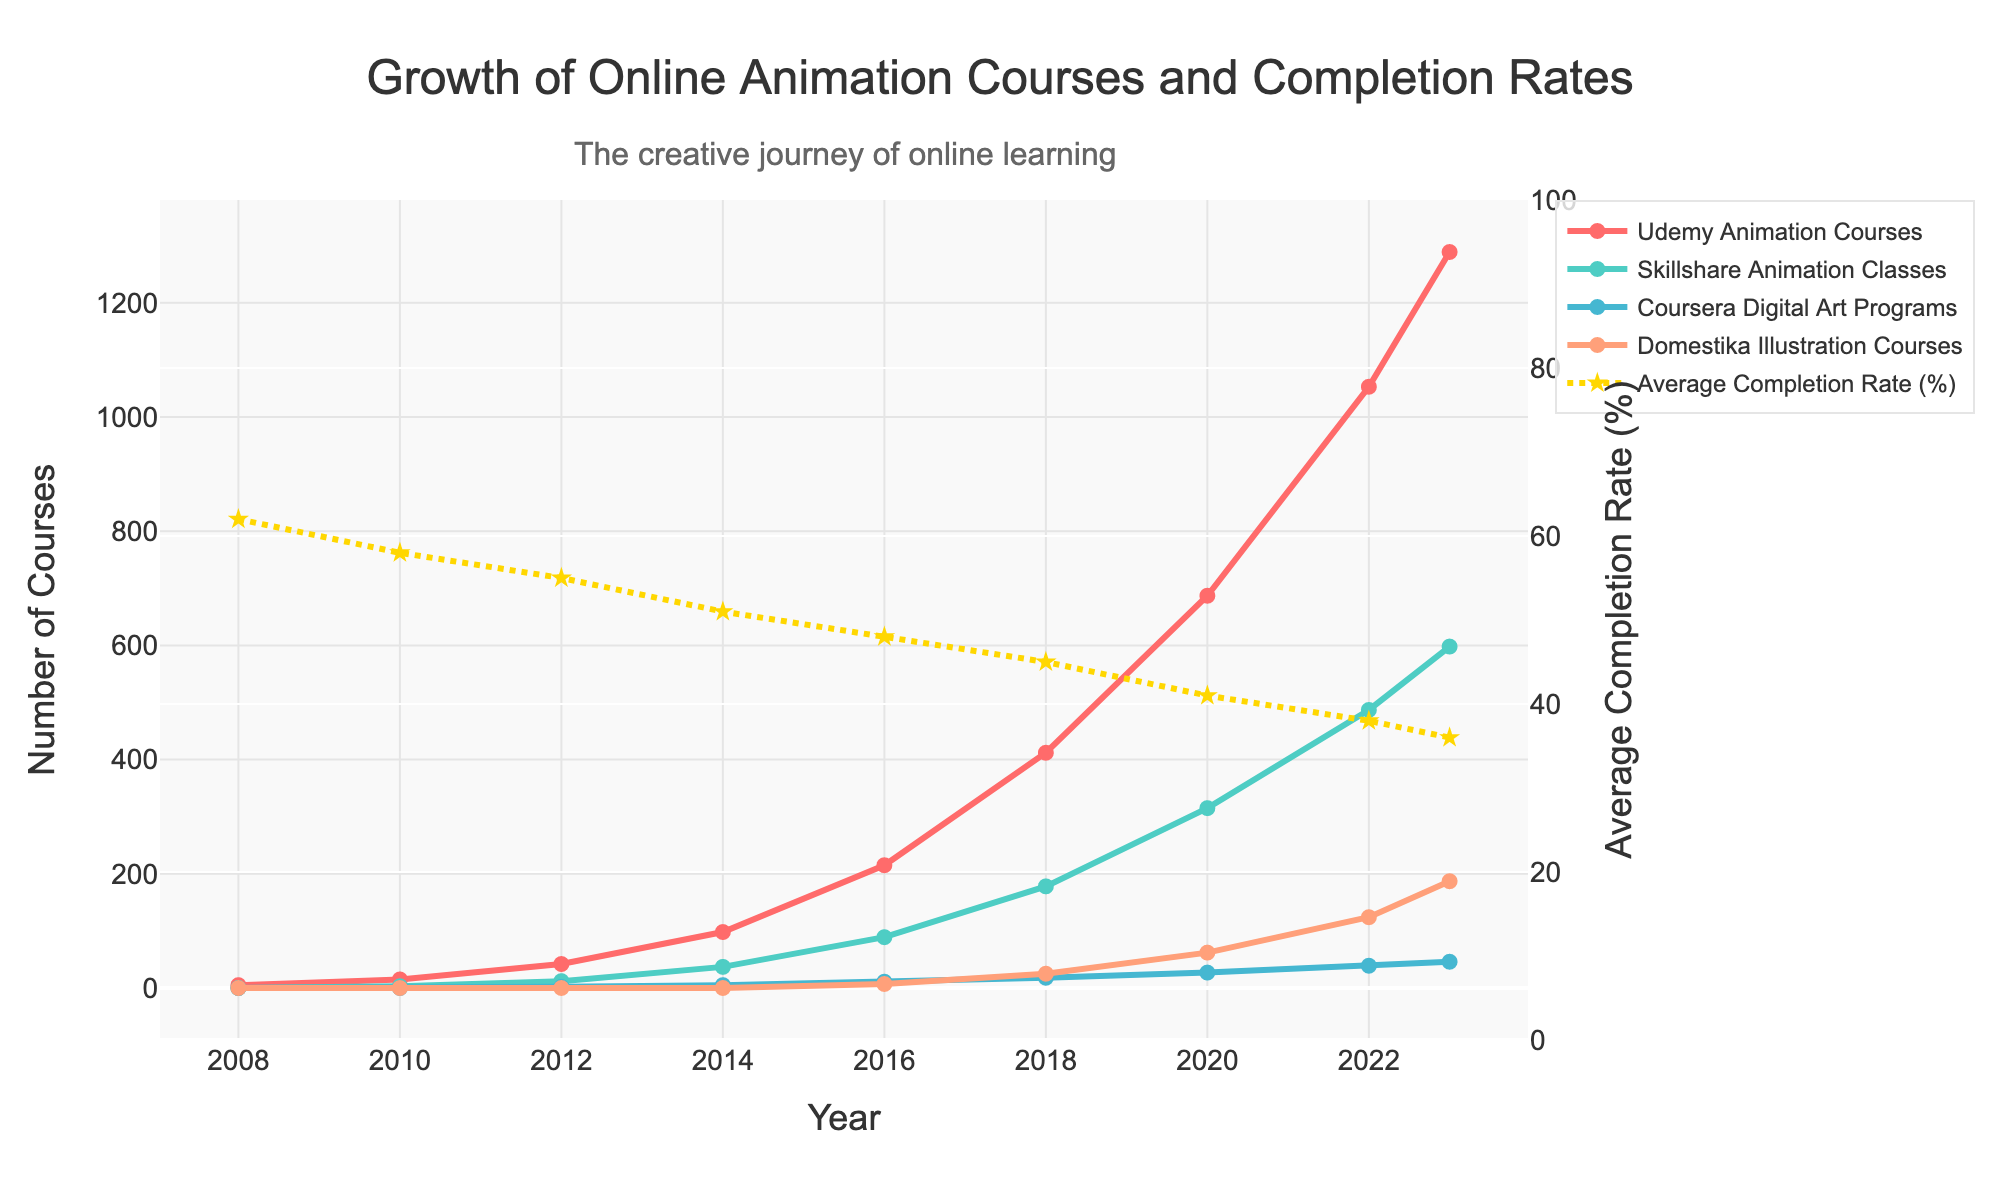What year had the largest increase in Udemy Animation Courses compared to the previous year? To determine the year with the largest increase in Udemy Animation Courses, calculate the difference in course numbers between consecutive years. From 2012 to 2014, the increase is 98 - 42 = 56 courses. From 2014 to 2016, the increase is 215 - 98 = 117 courses. From 2016 to 2018, the increase is 412 - 215 = 197 courses. From 2018 to 2020, the increase is 687 - 412 = 275 courses, and from 2020 to 2022, the increase is 1053 - 687 = 366 courses. The largest increase is between 2020 and 2022.
Answer: 2020-2022 How many total Skillshare Animation Classes were there in 2014 and 2016 combined? Add the number of Skillshare Animation Classes for the years 2014 and 2016. The number in 2014 is 37, and in 2016, it is 89. So, 37 + 89 = 126.
Answer: 126 Which course category had the least number of programs in 2020? Compare the number of programs for each course category in the year 2020. Udemy has 687, Skillshare has 315, Coursera has 27, and Domestika has 62. Coursera Digital Art Programs have the least number with 27.
Answer: Coursera Digital Art Programs What is the overall trend in the average completion rate from 2008 to 2023? Observe the line representing the Average Completion Rate (%). It starts at 62% in 2008 and decreases gradually over the years to reach 36% in 2023. The trend is a decline.
Answer: Decline How does the growth of Udemy Animation Courses from 2016 to 2018 compare to that of Domestika Illustration Courses in the same period? Calculate the increase in Udemy Animation Courses from 2016 to 2018 (412 - 215 = 197 courses) and compare it to the increase in Domestika Illustration Courses (25 - 7 = 18 courses) during the same period. Udemy's growth is significantly higher.
Answer: Udemy Animation Courses grew more What is the average number of Coursera Digital Art Programs between 2014 and 2023? Sum the number of programs for the given years: 5 (2014) + 11 (2016) + 18 (2018) + 27 (2020) + 39 (2022) + 46 (2023) = 146. There are 6 data points, so the average is 146 / 6 ≈ 24.3.
Answer: 24.3 Between 2012 and 2014, which platform saw the highest percentage increase in the number of animation courses offered? Calculate the percentage increase for each platform. Udemy: (98-42)/42 = 1.333 or 133.3%, Skillshare: (37-12)/12 = 2.083 or 208.3%, Coursera: (5-2)/2 = 1.5 or 150%, Domestika stays at 0, so Skillshare had the highest percentage increase.
Answer: Skillshare Which year shows the sharpest decline in the average completion rate? Compare the average completion rates across the years. The largest drop is seen from 2014 (51%) to 2016 (48%), where the completion rate decreased by 3 percentage points.
Answer: 2014-2016 By how much did the total number of online animation courses across all platforms grow from 2008 to 2023? Calculate the total number of courses in 2008 (5), and in 2023 (Udemy: 1289, Skillshare: 598, Coursera: 46, Domestika: 187), which sums up to 1289 + 598 + 46 + 187 = 2120. The growth is 2120 - 5 = 2115.
Answer: 2115 